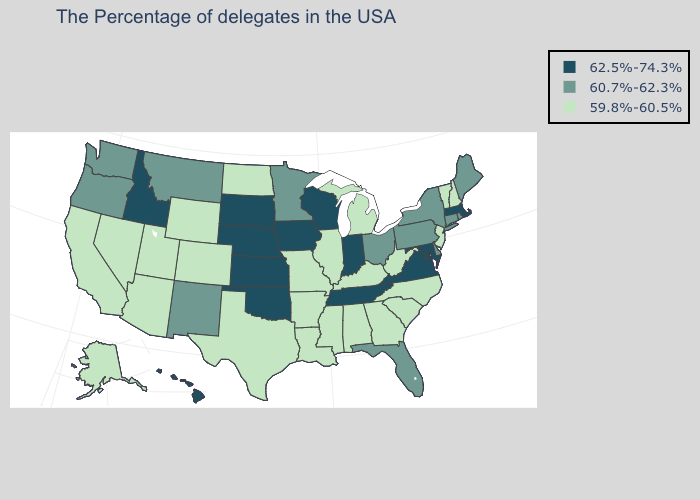What is the value of New Hampshire?
Give a very brief answer. 59.8%-60.5%. Which states hav the highest value in the South?
Keep it brief. Maryland, Virginia, Tennessee, Oklahoma. Does the map have missing data?
Short answer required. No. What is the lowest value in the USA?
Write a very short answer. 59.8%-60.5%. Does Michigan have a lower value than Washington?
Short answer required. Yes. What is the value of Indiana?
Concise answer only. 62.5%-74.3%. Name the states that have a value in the range 62.5%-74.3%?
Give a very brief answer. Massachusetts, Maryland, Virginia, Indiana, Tennessee, Wisconsin, Iowa, Kansas, Nebraska, Oklahoma, South Dakota, Idaho, Hawaii. Does Maryland have the same value as Arkansas?
Quick response, please. No. What is the highest value in the Northeast ?
Quick response, please. 62.5%-74.3%. How many symbols are there in the legend?
Short answer required. 3. Name the states that have a value in the range 59.8%-60.5%?
Quick response, please. New Hampshire, Vermont, New Jersey, North Carolina, South Carolina, West Virginia, Georgia, Michigan, Kentucky, Alabama, Illinois, Mississippi, Louisiana, Missouri, Arkansas, Texas, North Dakota, Wyoming, Colorado, Utah, Arizona, Nevada, California, Alaska. What is the value of Louisiana?
Answer briefly. 59.8%-60.5%. Does Indiana have the highest value in the MidWest?
Concise answer only. Yes. Does Alaska have a lower value than Idaho?
Short answer required. Yes. What is the highest value in the USA?
Keep it brief. 62.5%-74.3%. 